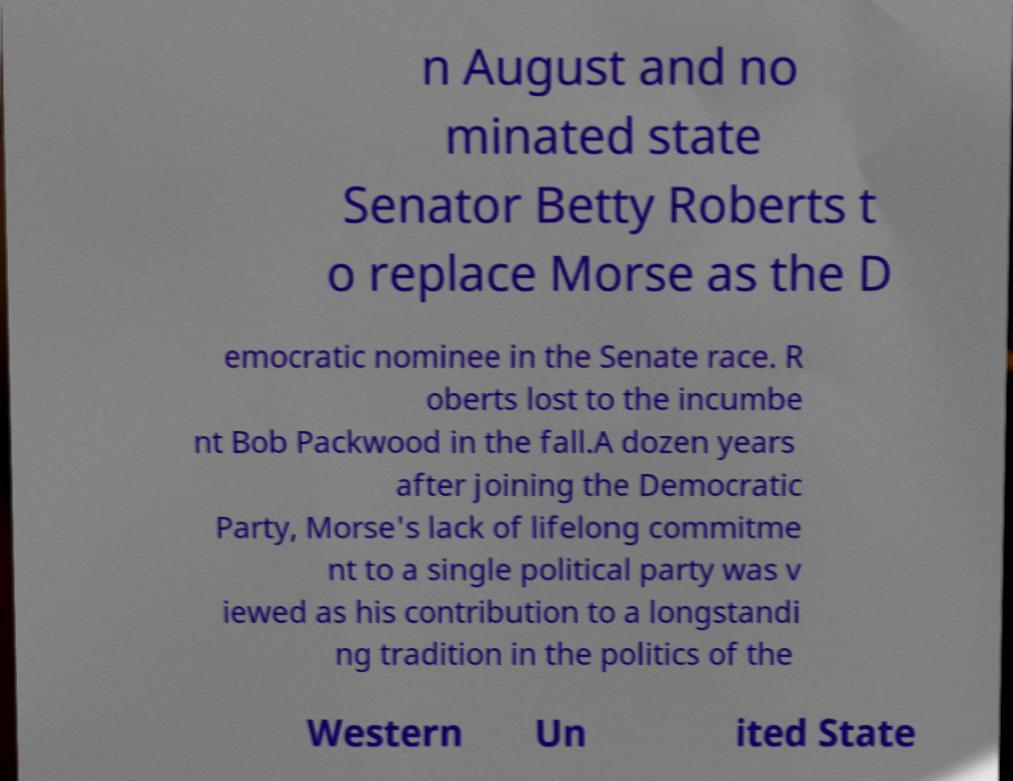Please read and relay the text visible in this image. What does it say? n August and no minated state Senator Betty Roberts t o replace Morse as the D emocratic nominee in the Senate race. R oberts lost to the incumbe nt Bob Packwood in the fall.A dozen years after joining the Democratic Party, Morse's lack of lifelong commitme nt to a single political party was v iewed as his contribution to a longstandi ng tradition in the politics of the Western Un ited State 